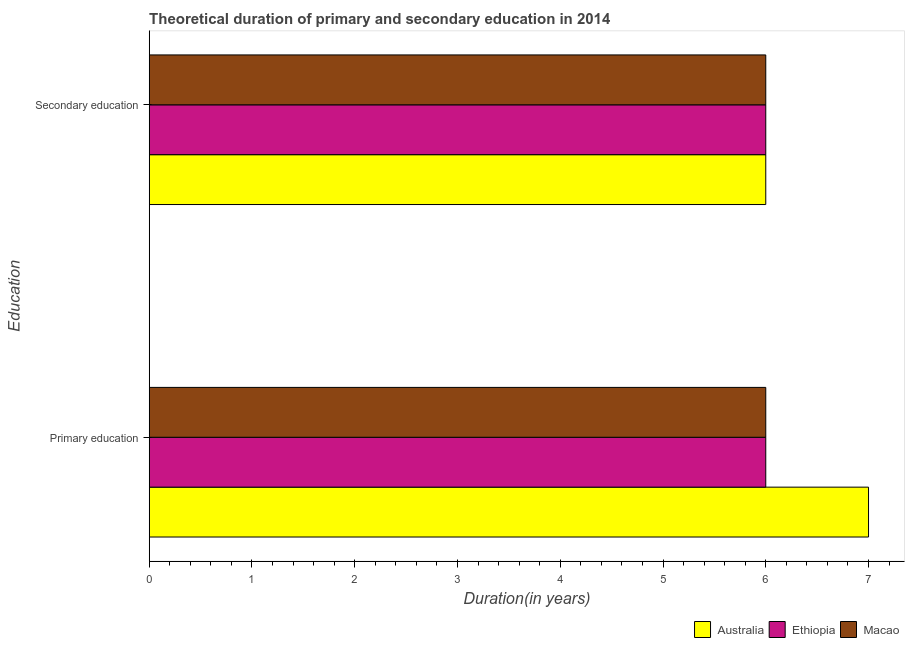How many different coloured bars are there?
Keep it short and to the point. 3. How many groups of bars are there?
Your response must be concise. 2. Are the number of bars per tick equal to the number of legend labels?
Ensure brevity in your answer.  Yes. How many bars are there on the 2nd tick from the bottom?
Provide a succinct answer. 3. What is the label of the 2nd group of bars from the top?
Your answer should be compact. Primary education. Across all countries, what is the maximum duration of primary education?
Your answer should be very brief. 7. What is the total duration of primary education in the graph?
Your answer should be very brief. 19. What is the difference between the duration of primary education in Ethiopia and that in Macao?
Keep it short and to the point. 0. What is the ratio of the duration of primary education in Ethiopia to that in Australia?
Your answer should be very brief. 0.86. In how many countries, is the duration of secondary education greater than the average duration of secondary education taken over all countries?
Your answer should be compact. 0. What does the 3rd bar from the bottom in Secondary education represents?
Provide a short and direct response. Macao. What is the difference between two consecutive major ticks on the X-axis?
Make the answer very short. 1. Are the values on the major ticks of X-axis written in scientific E-notation?
Your answer should be compact. No. Does the graph contain any zero values?
Offer a very short reply. No. Where does the legend appear in the graph?
Provide a succinct answer. Bottom right. How many legend labels are there?
Provide a short and direct response. 3. What is the title of the graph?
Your answer should be compact. Theoretical duration of primary and secondary education in 2014. What is the label or title of the X-axis?
Make the answer very short. Duration(in years). What is the label or title of the Y-axis?
Offer a very short reply. Education. What is the Duration(in years) in Ethiopia in Primary education?
Your response must be concise. 6. What is the Duration(in years) of Australia in Secondary education?
Your answer should be compact. 6. Across all Education, what is the maximum Duration(in years) of Ethiopia?
Provide a succinct answer. 6. Across all Education, what is the maximum Duration(in years) in Macao?
Offer a very short reply. 6. What is the total Duration(in years) in Australia in the graph?
Provide a short and direct response. 13. What is the total Duration(in years) in Ethiopia in the graph?
Provide a short and direct response. 12. What is the difference between the Duration(in years) of Ethiopia in Primary education and that in Secondary education?
Offer a terse response. 0. What is the difference between the Duration(in years) in Australia in Primary education and the Duration(in years) in Ethiopia in Secondary education?
Ensure brevity in your answer.  1. What is the difference between the Duration(in years) in Australia in Primary education and the Duration(in years) in Macao in Secondary education?
Provide a succinct answer. 1. What is the difference between the Duration(in years) of Ethiopia in Primary education and the Duration(in years) of Macao in Secondary education?
Offer a terse response. 0. What is the average Duration(in years) in Australia per Education?
Offer a very short reply. 6.5. What is the average Duration(in years) in Macao per Education?
Your answer should be compact. 6. What is the difference between the Duration(in years) in Australia and Duration(in years) in Ethiopia in Primary education?
Make the answer very short. 1. What is the ratio of the Duration(in years) of Australia in Primary education to that in Secondary education?
Your answer should be compact. 1.17. What is the ratio of the Duration(in years) of Macao in Primary education to that in Secondary education?
Your response must be concise. 1. What is the difference between the highest and the lowest Duration(in years) of Australia?
Make the answer very short. 1. What is the difference between the highest and the lowest Duration(in years) in Ethiopia?
Give a very brief answer. 0. What is the difference between the highest and the lowest Duration(in years) in Macao?
Provide a succinct answer. 0. 